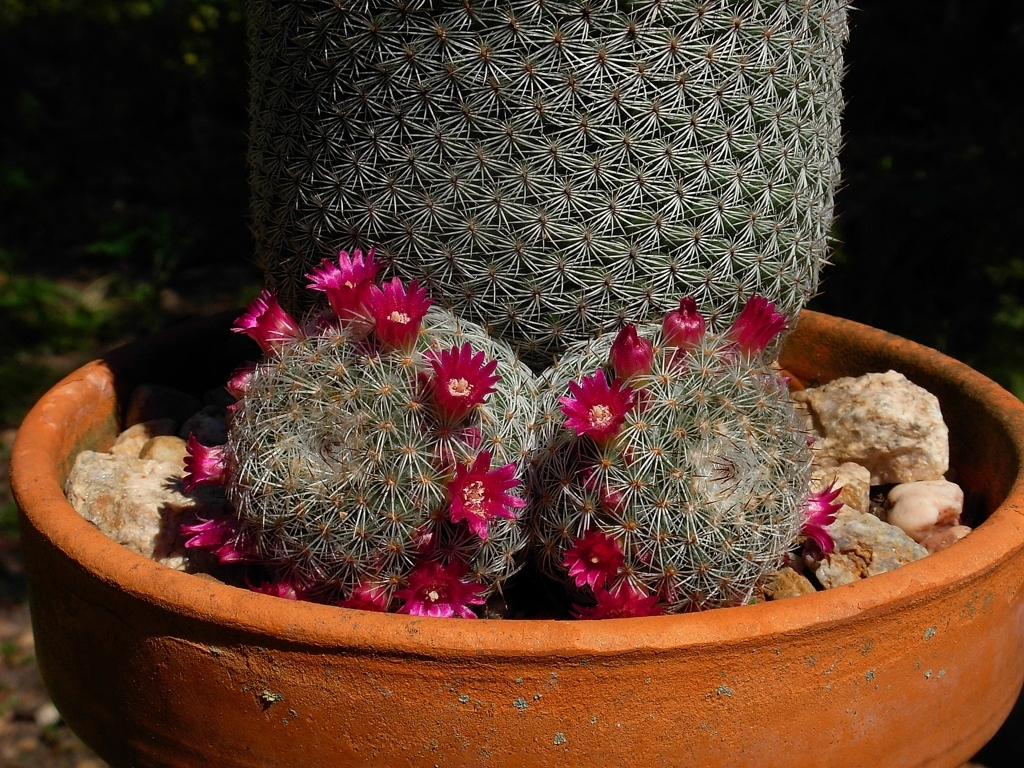What is the condition of the terracotta pot? The terracotta pot appears to be in good condition with a classic weathered look that many gardeners find appealing. Its earthy tones complement the natural aesthetic of the cactus, creating a harmonious display. 